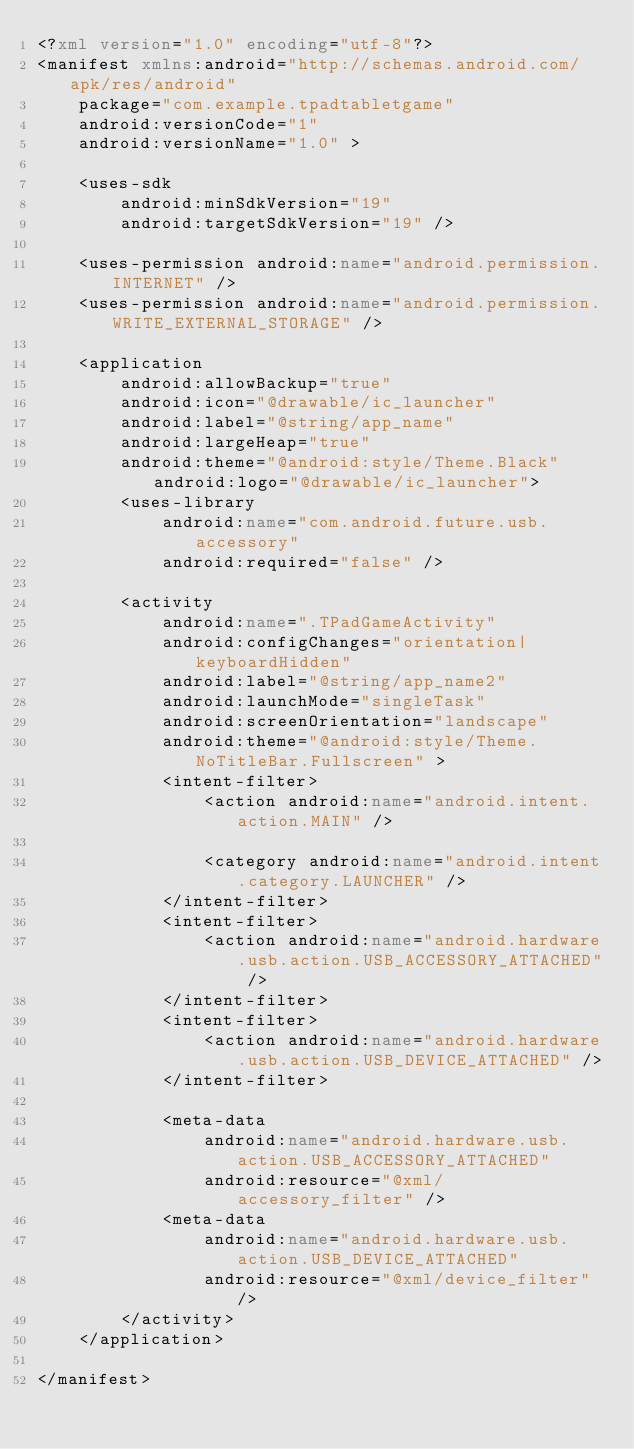<code> <loc_0><loc_0><loc_500><loc_500><_XML_><?xml version="1.0" encoding="utf-8"?>
<manifest xmlns:android="http://schemas.android.com/apk/res/android"
    package="com.example.tpadtabletgame"
    android:versionCode="1"
    android:versionName="1.0" >

    <uses-sdk
        android:minSdkVersion="19"
        android:targetSdkVersion="19" />

    <uses-permission android:name="android.permission.INTERNET" />
    <uses-permission android:name="android.permission.WRITE_EXTERNAL_STORAGE" />

    <application
        android:allowBackup="true"
        android:icon="@drawable/ic_launcher"
        android:label="@string/app_name"
        android:largeHeap="true"
        android:theme="@android:style/Theme.Black" android:logo="@drawable/ic_launcher">
        <uses-library
            android:name="com.android.future.usb.accessory"
            android:required="false" />

        <activity
            android:name=".TPadGameActivity"
            android:configChanges="orientation|keyboardHidden"
            android:label="@string/app_name2"
            android:launchMode="singleTask"
            android:screenOrientation="landscape"
            android:theme="@android:style/Theme.NoTitleBar.Fullscreen" >
            <intent-filter>
                <action android:name="android.intent.action.MAIN" />

                <category android:name="android.intent.category.LAUNCHER" />
            </intent-filter>
            <intent-filter>
                <action android:name="android.hardware.usb.action.USB_ACCESSORY_ATTACHED" />
            </intent-filter>
            <intent-filter>
                <action android:name="android.hardware.usb.action.USB_DEVICE_ATTACHED" />
            </intent-filter>

            <meta-data
                android:name="android.hardware.usb.action.USB_ACCESSORY_ATTACHED"
                android:resource="@xml/accessory_filter" />
            <meta-data
                android:name="android.hardware.usb.action.USB_DEVICE_ATTACHED"
                android:resource="@xml/device_filter" />
        </activity>
    </application>

</manifest></code> 